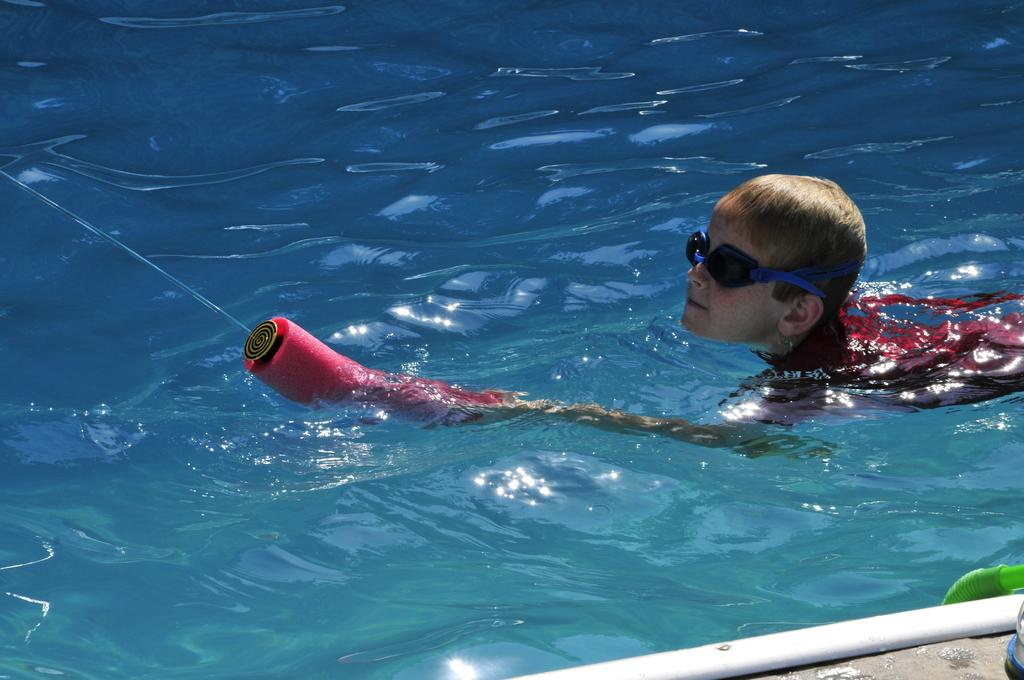Who is the main subject in the image? There is a boy in the image. What is the boy doing in the image? The boy is swimming in the water. What is the boy holding in the image? The boy is holding an object. What color are the clothes the boy is wearing? The boy is wearing red clothes. Where is the boy's grandfather in the image? There is no grandfather present in the image. What is stored in the cellar in the image? There is no cellar present in the image. 